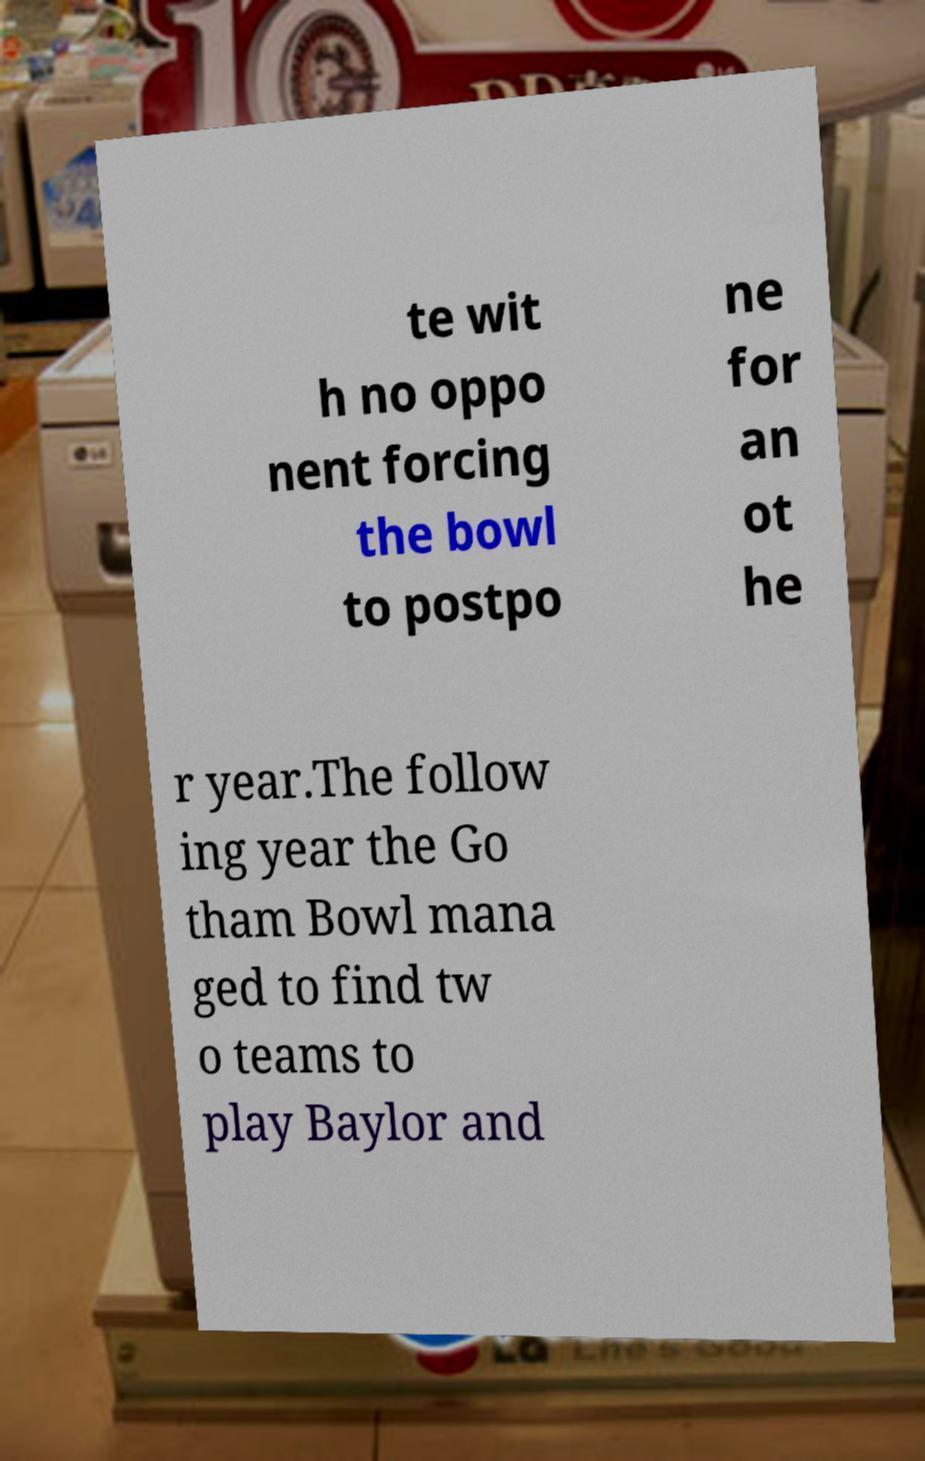Please identify and transcribe the text found in this image. te wit h no oppo nent forcing the bowl to postpo ne for an ot he r year.The follow ing year the Go tham Bowl mana ged to find tw o teams to play Baylor and 